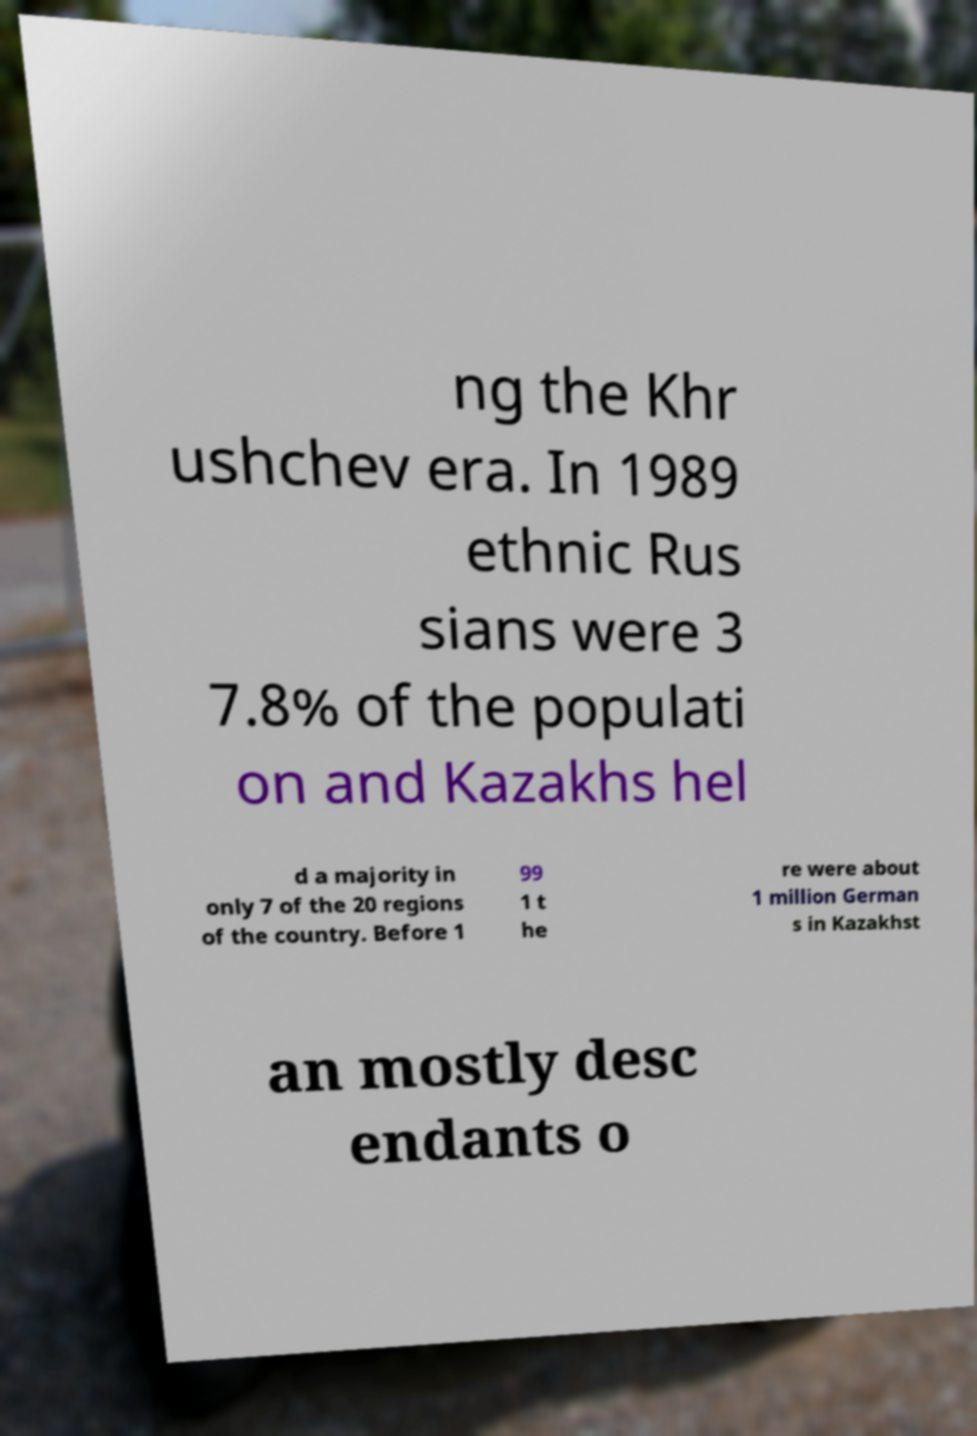Could you extract and type out the text from this image? ng the Khr ushchev era. In 1989 ethnic Rus sians were 3 7.8% of the populati on and Kazakhs hel d a majority in only 7 of the 20 regions of the country. Before 1 99 1 t he re were about 1 million German s in Kazakhst an mostly desc endants o 